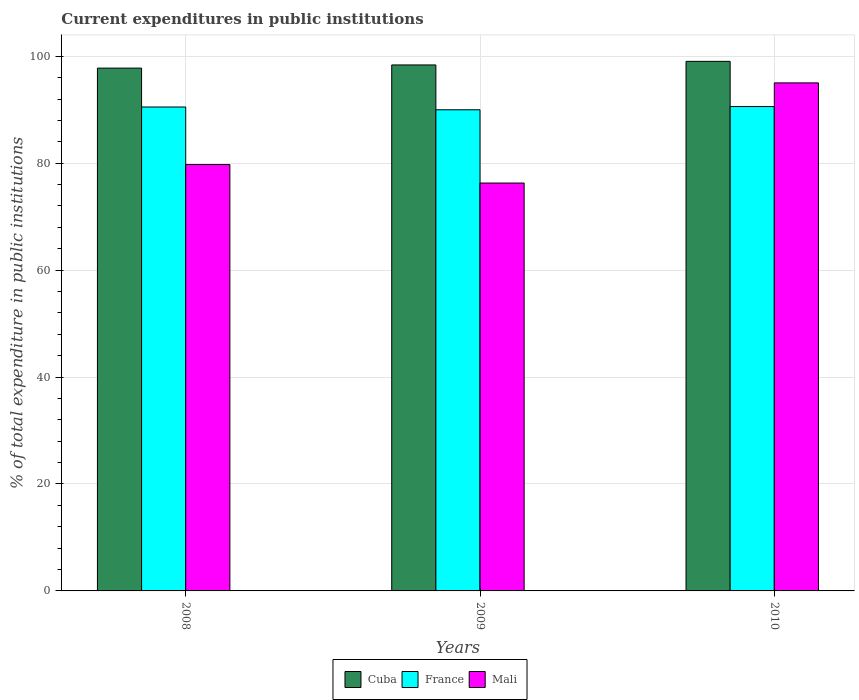How many bars are there on the 1st tick from the left?
Your answer should be very brief. 3. How many bars are there on the 3rd tick from the right?
Your answer should be compact. 3. What is the label of the 1st group of bars from the left?
Give a very brief answer. 2008. In how many cases, is the number of bars for a given year not equal to the number of legend labels?
Provide a short and direct response. 0. What is the current expenditures in public institutions in Mali in 2009?
Offer a very short reply. 76.29. Across all years, what is the maximum current expenditures in public institutions in France?
Keep it short and to the point. 90.59. Across all years, what is the minimum current expenditures in public institutions in Mali?
Provide a short and direct response. 76.29. What is the total current expenditures in public institutions in Cuba in the graph?
Your response must be concise. 295.21. What is the difference between the current expenditures in public institutions in Mali in 2008 and that in 2010?
Your response must be concise. -15.27. What is the difference between the current expenditures in public institutions in Cuba in 2008 and the current expenditures in public institutions in Mali in 2010?
Give a very brief answer. 2.76. What is the average current expenditures in public institutions in Cuba per year?
Your answer should be very brief. 98.4. In the year 2009, what is the difference between the current expenditures in public institutions in France and current expenditures in public institutions in Mali?
Make the answer very short. 13.7. In how many years, is the current expenditures in public institutions in France greater than 88 %?
Keep it short and to the point. 3. What is the ratio of the current expenditures in public institutions in Cuba in 2008 to that in 2010?
Give a very brief answer. 0.99. Is the current expenditures in public institutions in Cuba in 2008 less than that in 2009?
Give a very brief answer. Yes. Is the difference between the current expenditures in public institutions in France in 2008 and 2010 greater than the difference between the current expenditures in public institutions in Mali in 2008 and 2010?
Offer a terse response. Yes. What is the difference between the highest and the second highest current expenditures in public institutions in France?
Your answer should be very brief. 0.08. What is the difference between the highest and the lowest current expenditures in public institutions in Cuba?
Give a very brief answer. 1.26. What does the 3rd bar from the left in 2009 represents?
Make the answer very short. Mali. What does the 2nd bar from the right in 2010 represents?
Make the answer very short. France. How many bars are there?
Offer a very short reply. 9. How many years are there in the graph?
Ensure brevity in your answer.  3. What is the difference between two consecutive major ticks on the Y-axis?
Ensure brevity in your answer.  20. Are the values on the major ticks of Y-axis written in scientific E-notation?
Give a very brief answer. No. Where does the legend appear in the graph?
Provide a short and direct response. Bottom center. What is the title of the graph?
Your response must be concise. Current expenditures in public institutions. Does "Poland" appear as one of the legend labels in the graph?
Offer a terse response. No. What is the label or title of the X-axis?
Offer a very short reply. Years. What is the label or title of the Y-axis?
Provide a succinct answer. % of total expenditure in public institutions. What is the % of total expenditure in public institutions in Cuba in 2008?
Your answer should be very brief. 97.78. What is the % of total expenditure in public institutions in France in 2008?
Ensure brevity in your answer.  90.51. What is the % of total expenditure in public institutions of Mali in 2008?
Your response must be concise. 79.75. What is the % of total expenditure in public institutions in Cuba in 2009?
Your response must be concise. 98.38. What is the % of total expenditure in public institutions in France in 2009?
Your answer should be very brief. 89.99. What is the % of total expenditure in public institutions of Mali in 2009?
Your answer should be compact. 76.29. What is the % of total expenditure in public institutions of Cuba in 2010?
Your response must be concise. 99.05. What is the % of total expenditure in public institutions of France in 2010?
Keep it short and to the point. 90.59. What is the % of total expenditure in public institutions in Mali in 2010?
Your response must be concise. 95.02. Across all years, what is the maximum % of total expenditure in public institutions of Cuba?
Your answer should be very brief. 99.05. Across all years, what is the maximum % of total expenditure in public institutions of France?
Your response must be concise. 90.59. Across all years, what is the maximum % of total expenditure in public institutions in Mali?
Offer a terse response. 95.02. Across all years, what is the minimum % of total expenditure in public institutions of Cuba?
Ensure brevity in your answer.  97.78. Across all years, what is the minimum % of total expenditure in public institutions of France?
Provide a short and direct response. 89.99. Across all years, what is the minimum % of total expenditure in public institutions in Mali?
Keep it short and to the point. 76.29. What is the total % of total expenditure in public institutions in Cuba in the graph?
Your response must be concise. 295.21. What is the total % of total expenditure in public institutions of France in the graph?
Offer a terse response. 271.09. What is the total % of total expenditure in public institutions in Mali in the graph?
Keep it short and to the point. 251.06. What is the difference between the % of total expenditure in public institutions of Cuba in 2008 and that in 2009?
Ensure brevity in your answer.  -0.59. What is the difference between the % of total expenditure in public institutions in France in 2008 and that in 2009?
Give a very brief answer. 0.52. What is the difference between the % of total expenditure in public institutions in Mali in 2008 and that in 2009?
Your answer should be very brief. 3.46. What is the difference between the % of total expenditure in public institutions in Cuba in 2008 and that in 2010?
Provide a succinct answer. -1.26. What is the difference between the % of total expenditure in public institutions in France in 2008 and that in 2010?
Keep it short and to the point. -0.08. What is the difference between the % of total expenditure in public institutions in Mali in 2008 and that in 2010?
Provide a short and direct response. -15.27. What is the difference between the % of total expenditure in public institutions of Cuba in 2009 and that in 2010?
Offer a very short reply. -0.67. What is the difference between the % of total expenditure in public institutions of France in 2009 and that in 2010?
Provide a succinct answer. -0.6. What is the difference between the % of total expenditure in public institutions in Mali in 2009 and that in 2010?
Provide a succinct answer. -18.73. What is the difference between the % of total expenditure in public institutions in Cuba in 2008 and the % of total expenditure in public institutions in France in 2009?
Provide a short and direct response. 7.79. What is the difference between the % of total expenditure in public institutions in Cuba in 2008 and the % of total expenditure in public institutions in Mali in 2009?
Make the answer very short. 21.49. What is the difference between the % of total expenditure in public institutions in France in 2008 and the % of total expenditure in public institutions in Mali in 2009?
Your response must be concise. 14.22. What is the difference between the % of total expenditure in public institutions in Cuba in 2008 and the % of total expenditure in public institutions in France in 2010?
Your answer should be very brief. 7.19. What is the difference between the % of total expenditure in public institutions of Cuba in 2008 and the % of total expenditure in public institutions of Mali in 2010?
Your answer should be compact. 2.76. What is the difference between the % of total expenditure in public institutions of France in 2008 and the % of total expenditure in public institutions of Mali in 2010?
Make the answer very short. -4.51. What is the difference between the % of total expenditure in public institutions of Cuba in 2009 and the % of total expenditure in public institutions of France in 2010?
Offer a very short reply. 7.78. What is the difference between the % of total expenditure in public institutions of Cuba in 2009 and the % of total expenditure in public institutions of Mali in 2010?
Give a very brief answer. 3.36. What is the difference between the % of total expenditure in public institutions in France in 2009 and the % of total expenditure in public institutions in Mali in 2010?
Your response must be concise. -5.03. What is the average % of total expenditure in public institutions of Cuba per year?
Your answer should be very brief. 98.4. What is the average % of total expenditure in public institutions in France per year?
Give a very brief answer. 90.36. What is the average % of total expenditure in public institutions of Mali per year?
Provide a short and direct response. 83.69. In the year 2008, what is the difference between the % of total expenditure in public institutions in Cuba and % of total expenditure in public institutions in France?
Offer a terse response. 7.27. In the year 2008, what is the difference between the % of total expenditure in public institutions in Cuba and % of total expenditure in public institutions in Mali?
Offer a terse response. 18.03. In the year 2008, what is the difference between the % of total expenditure in public institutions of France and % of total expenditure in public institutions of Mali?
Your response must be concise. 10.76. In the year 2009, what is the difference between the % of total expenditure in public institutions of Cuba and % of total expenditure in public institutions of France?
Your answer should be compact. 8.39. In the year 2009, what is the difference between the % of total expenditure in public institutions in Cuba and % of total expenditure in public institutions in Mali?
Give a very brief answer. 22.09. In the year 2009, what is the difference between the % of total expenditure in public institutions of France and % of total expenditure in public institutions of Mali?
Your answer should be very brief. 13.7. In the year 2010, what is the difference between the % of total expenditure in public institutions of Cuba and % of total expenditure in public institutions of France?
Your answer should be very brief. 8.46. In the year 2010, what is the difference between the % of total expenditure in public institutions in Cuba and % of total expenditure in public institutions in Mali?
Give a very brief answer. 4.03. In the year 2010, what is the difference between the % of total expenditure in public institutions of France and % of total expenditure in public institutions of Mali?
Your response must be concise. -4.43. What is the ratio of the % of total expenditure in public institutions in Mali in 2008 to that in 2009?
Keep it short and to the point. 1.05. What is the ratio of the % of total expenditure in public institutions in Cuba in 2008 to that in 2010?
Provide a succinct answer. 0.99. What is the ratio of the % of total expenditure in public institutions in France in 2008 to that in 2010?
Your answer should be very brief. 1. What is the ratio of the % of total expenditure in public institutions of Mali in 2008 to that in 2010?
Ensure brevity in your answer.  0.84. What is the ratio of the % of total expenditure in public institutions in Mali in 2009 to that in 2010?
Provide a succinct answer. 0.8. What is the difference between the highest and the second highest % of total expenditure in public institutions of Cuba?
Make the answer very short. 0.67. What is the difference between the highest and the second highest % of total expenditure in public institutions in France?
Provide a succinct answer. 0.08. What is the difference between the highest and the second highest % of total expenditure in public institutions of Mali?
Your response must be concise. 15.27. What is the difference between the highest and the lowest % of total expenditure in public institutions in Cuba?
Provide a succinct answer. 1.26. What is the difference between the highest and the lowest % of total expenditure in public institutions of France?
Your answer should be compact. 0.6. What is the difference between the highest and the lowest % of total expenditure in public institutions of Mali?
Provide a short and direct response. 18.73. 